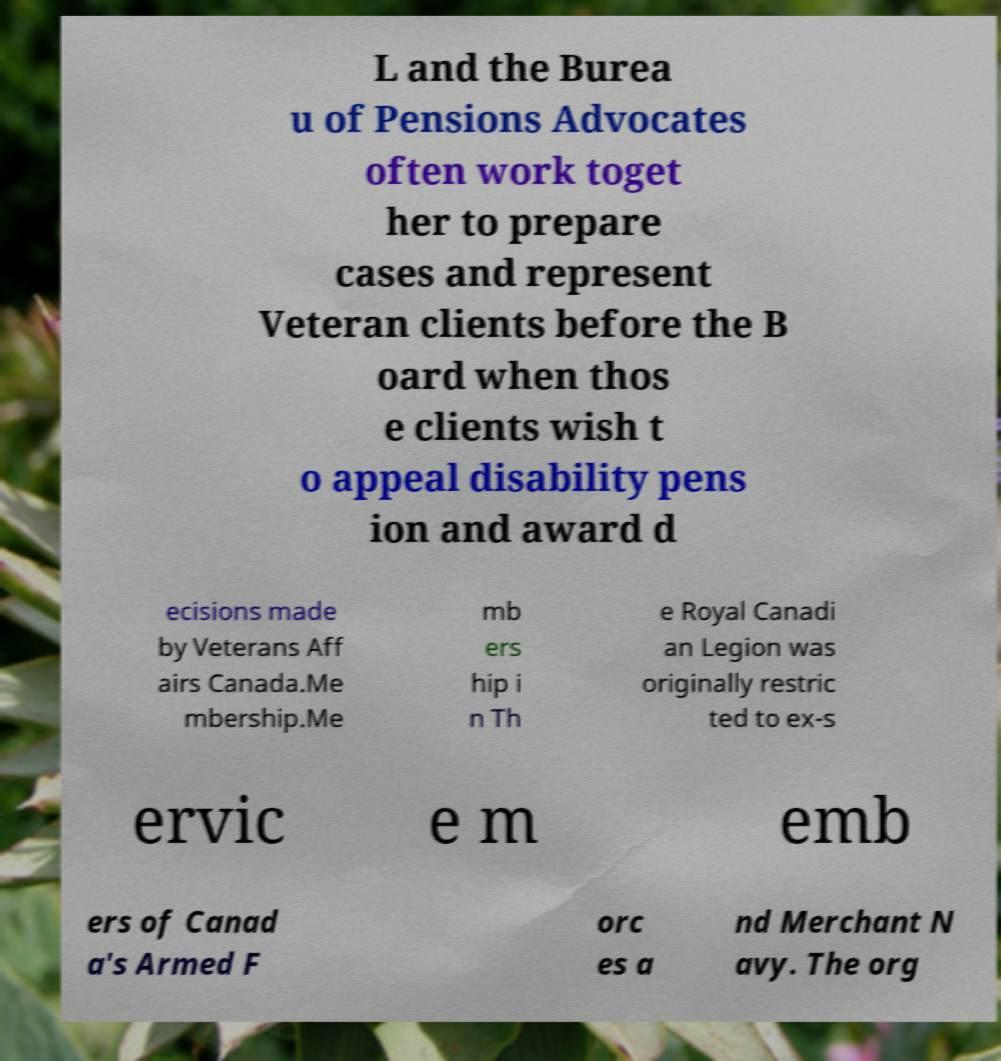Could you assist in decoding the text presented in this image and type it out clearly? L and the Burea u of Pensions Advocates often work toget her to prepare cases and represent Veteran clients before the B oard when thos e clients wish t o appeal disability pens ion and award d ecisions made by Veterans Aff airs Canada.Me mbership.Me mb ers hip i n Th e Royal Canadi an Legion was originally restric ted to ex-s ervic e m emb ers of Canad a's Armed F orc es a nd Merchant N avy. The org 